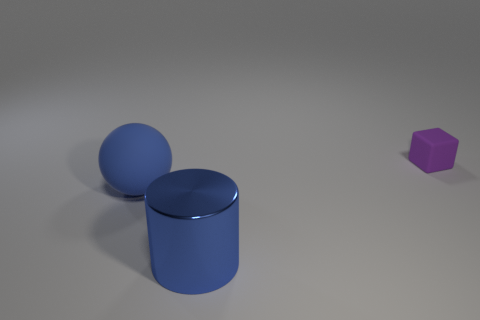Is there any other thing that is the same size as the blue sphere? While the sizes can be difficult to judge precisely because of perspective and potential differences in distance from the viewer, the blue cylinder appears to be of a similar diameter to the blue sphere, but its height is different. 